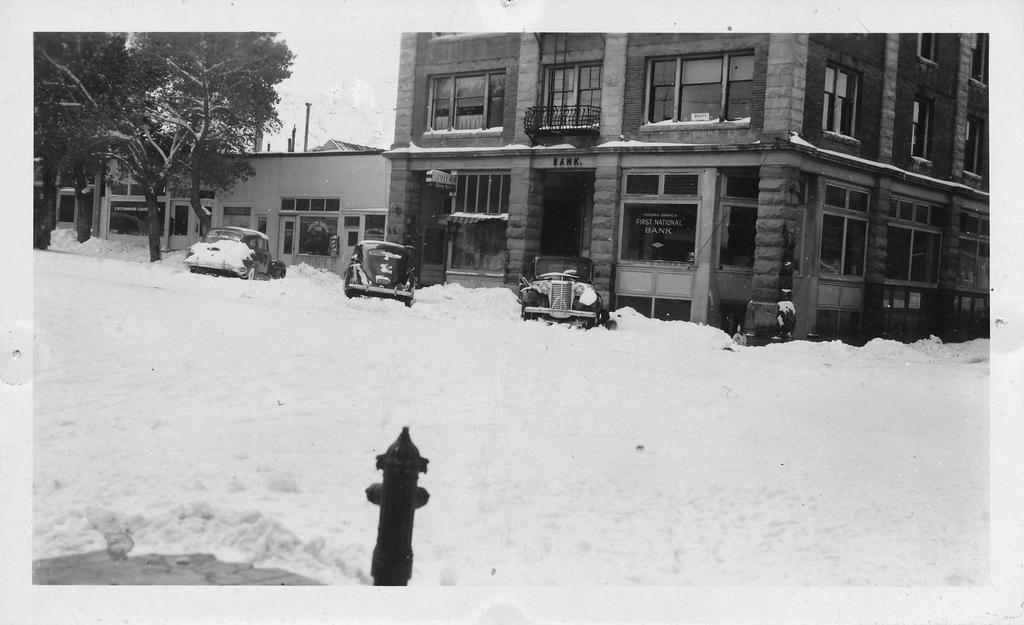Could you give a brief overview of what you see in this image? This is a black and white picture. Here we can see a hydrant, snow, vehicles, trees, poles, and buildings. In the background there is sky. 